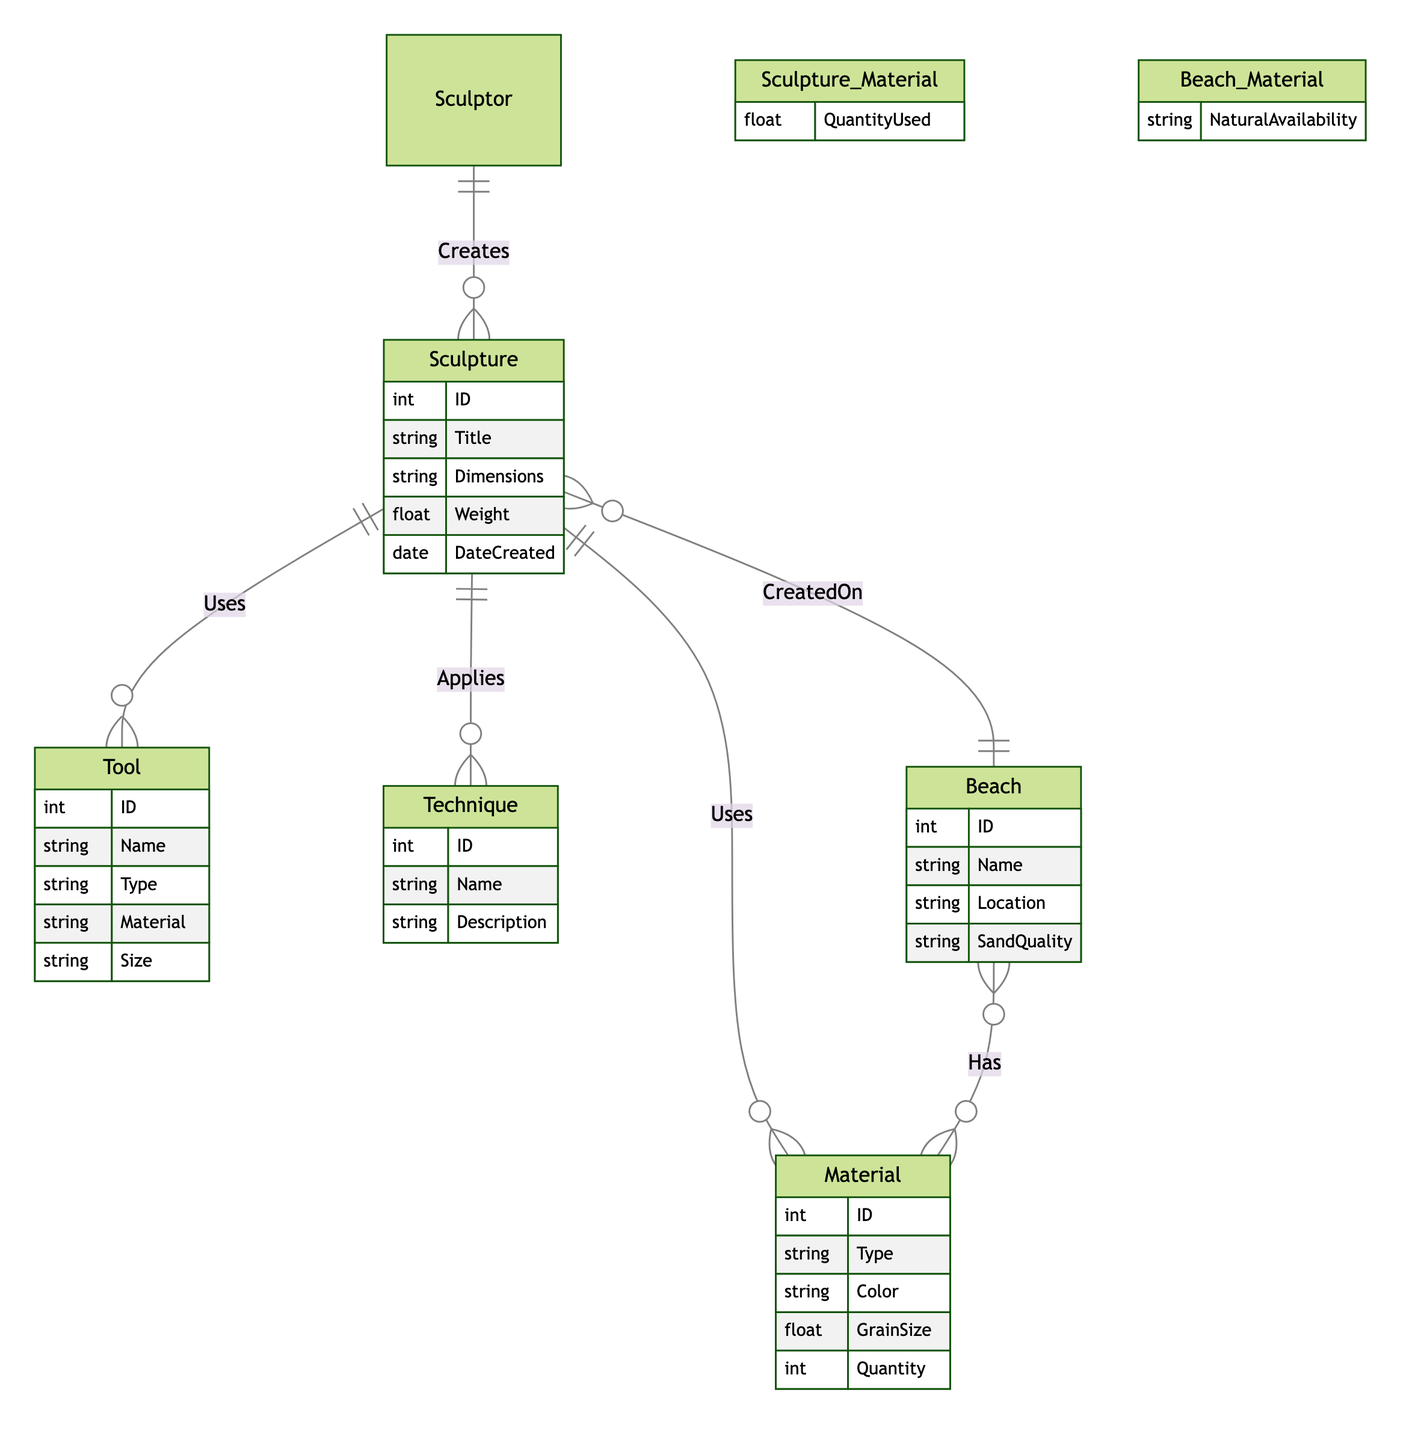What is the primary relationship between Sculpture and Material? The diagram indicates that the Sculpture entity uses Material in a many-to-many relationship, showing that each sculpture can consist of multiple materials and each material can be used in multiple sculptures.
Answer: Uses How many attributes does the Technique entity have? By inspecting the Technique entity description in the diagram, it reveals that there are three attributes: ID, Name, and Description, allowing us to count them.
Answer: Three What type of relationship is between Sculpture and Beach? The diagram shows that the relationship between Sculpture and Beach is many-to-one, indicating that multiple sculptures can be created on a single beach, but each sculpture is associated with only one beach.
Answer: Many-to-one What additional attribute is present in the Sculpture_Material relationship? The additional attribute present in the Sculpture_Material relationship indicates the QuantityUsed, which describes how much of a certain material is used in a specific sculpture.
Answer: QuantityUsed What is the key entity involved in the one-to-many relationship with Sculpture? The diagram reveals that the Sculptor entity is involved in a one-to-many relationship with Sculpture, which highlights that one sculptor can create multiple sculptures.
Answer: Sculptor Which entity has the attribute 'SandQuality'? Upon reviewing the diagram, it is clear that the Beach entity includes the attribute named SandQuality, indicating information about the quality of sand at a particular beach.
Answer: Beach What is the maximum number of materials that can be used in a Sculpture based on the diagram? Since the relationship between Sculpture and Material is many-to-many, theoretically there is no upper limit specified in the diagram for the number of materials that a sculpture can utilize. However, practical limits would exist.
Answer: Unlimited How many entities are related to Sculpture in a many-to-many relationship? The diagram shows three entities—Material, Tool, and Technique—each connected to Sculpture in a many-to-many relationship, allowing for collaborative use of various tools, techniques, and materials in sculpture creation.
Answer: Three 